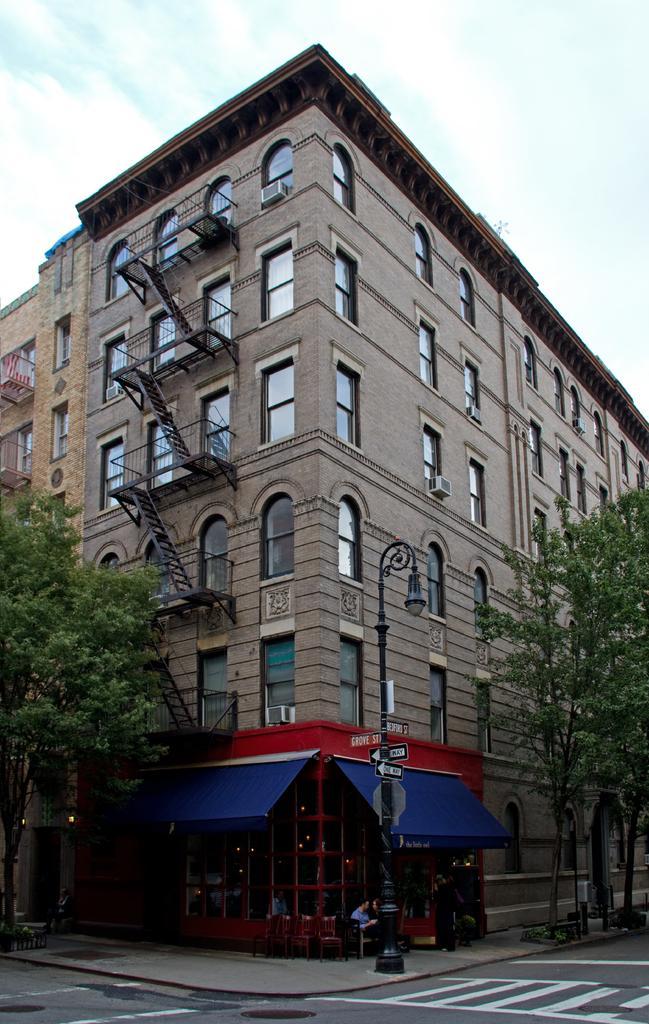Describe this image in one or two sentences. In the center of the picture there are trees, building, staircases, windows, street light and other objects. In the foreground it is road. 